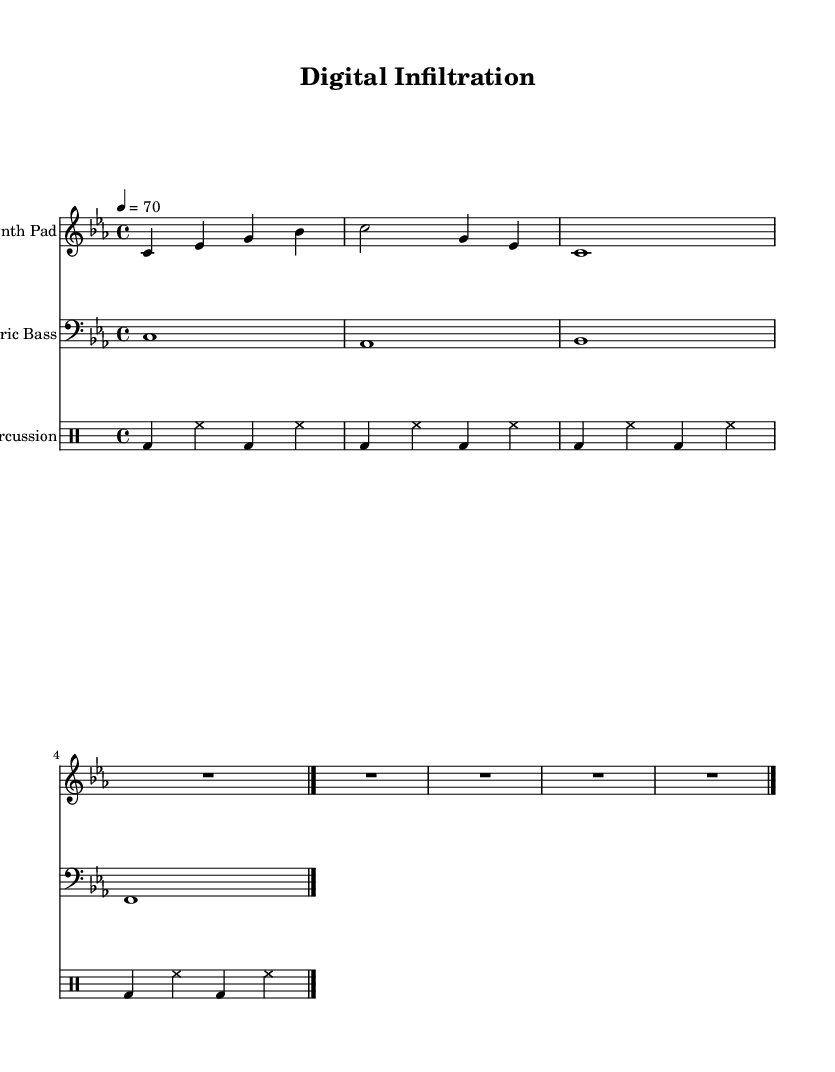What is the key signature of this music? The key signature is identified by the presence of flat or sharp symbols placed at the beginning of the staff. In this case, there are no flat or sharp symbols, indicating the key is C minor.
Answer: C minor What is the time signature of this music? The time signature indicates how many beats are in each measure. In this sheet music, the time signature is shown as 4/4, which means there are four beats in each measure.
Answer: 4/4 What is the tempo marking in this piece? The tempo marking is given at the beginning of the score and indicates how fast the piece should be played. Here, it states "4 = 70," meaning each quarter note is played at a speed of 70 beats per minute.
Answer: 70 How many measures are there in the synth pad part? The synth pad part consists of four measures, which can be counted by recognizing the vertical lines (barlines) separating each measure. The last barline indicates the end of the part.
Answer: 4 What type of percussion instruments are used in this music? The percussion section typically includes drums, and in this piece, the notation explicitly allows for bass drum and hi-hat symbols. These symbols indicate that an acoustic style is used here.
Answer: Bass drum and hi-hat What is the longest note value in the electric bass part? The electric bass part features a whole note, indicated by the shape of the note head and its duration, which is sustained for a full measure, making it the longest note value in the part.
Answer: Whole note What characterizes the synth pad from the other instruments in terms of texture? The synth pad has a smoother, more sustained sound texture compared to the rhythmic and percussive nature of the electric bass and percussion parts. This makes it stand out as atmospheric music typically used in ambient soundtracks.
Answer: Smoother and sustained texture 